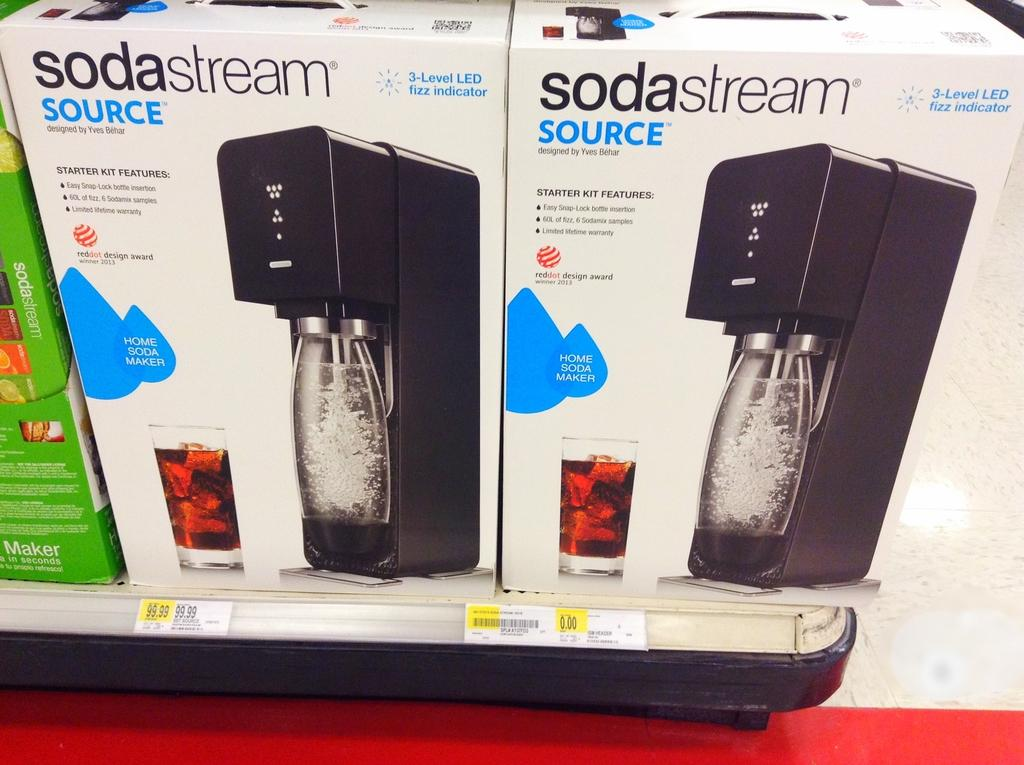<image>
Render a clear and concise summary of the photo. Two boxes containing a sodastream source are in a store. 